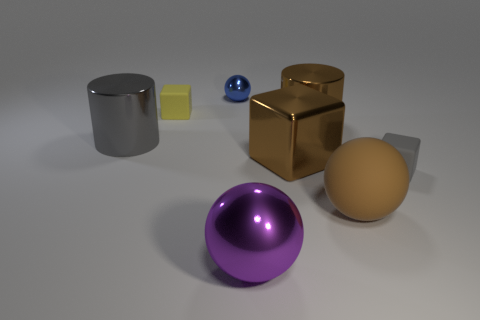Subtract all tiny matte cubes. How many cubes are left? 1 Add 1 metallic blocks. How many objects exist? 9 Subtract all blue spheres. How many spheres are left? 2 Subtract 1 brown balls. How many objects are left? 7 Subtract all cylinders. How many objects are left? 6 Subtract 2 cylinders. How many cylinders are left? 0 Subtract all green cylinders. Subtract all blue spheres. How many cylinders are left? 2 Subtract all gray matte blocks. Subtract all brown metallic objects. How many objects are left? 5 Add 4 purple shiny objects. How many purple shiny objects are left? 5 Add 3 big cyan blocks. How many big cyan blocks exist? 3 